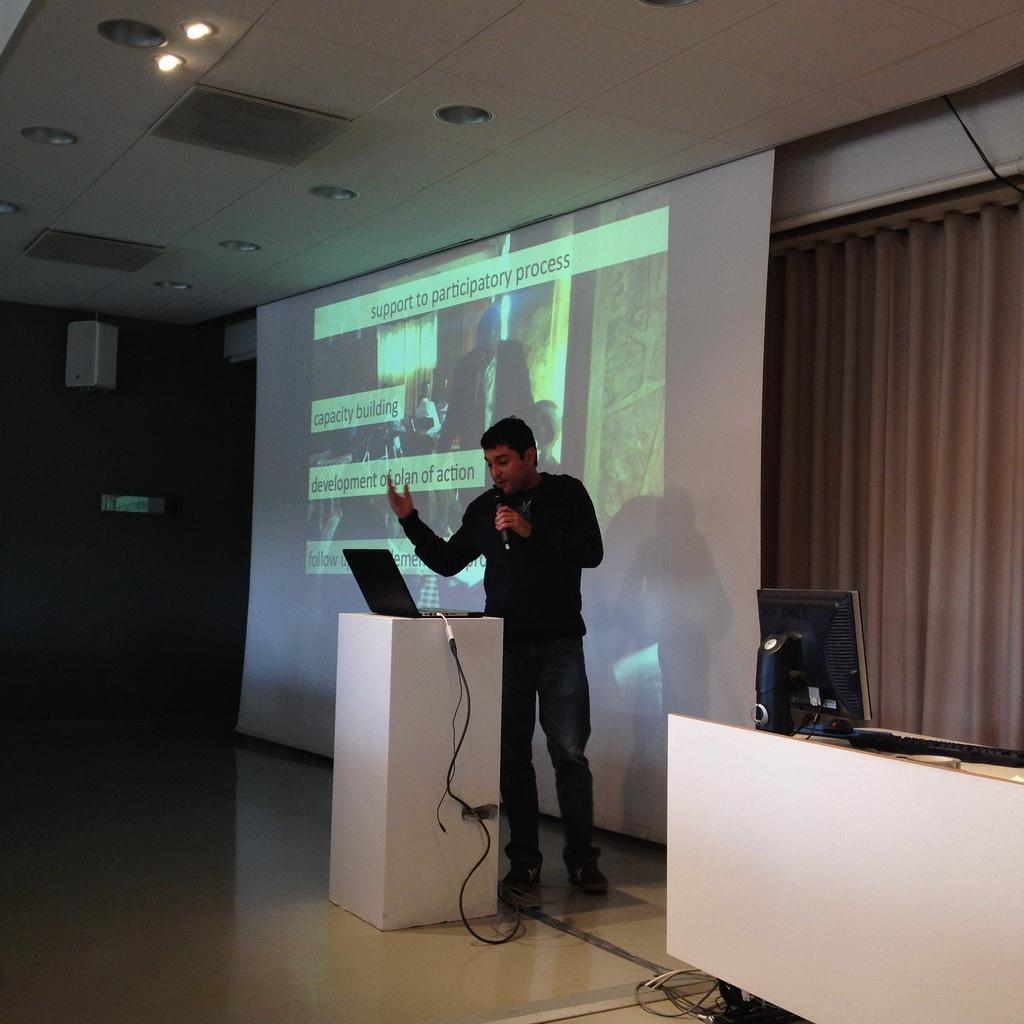<image>
Write a terse but informative summary of the picture. man giving lecture with projection behind him showing "support to participatory process" at top 